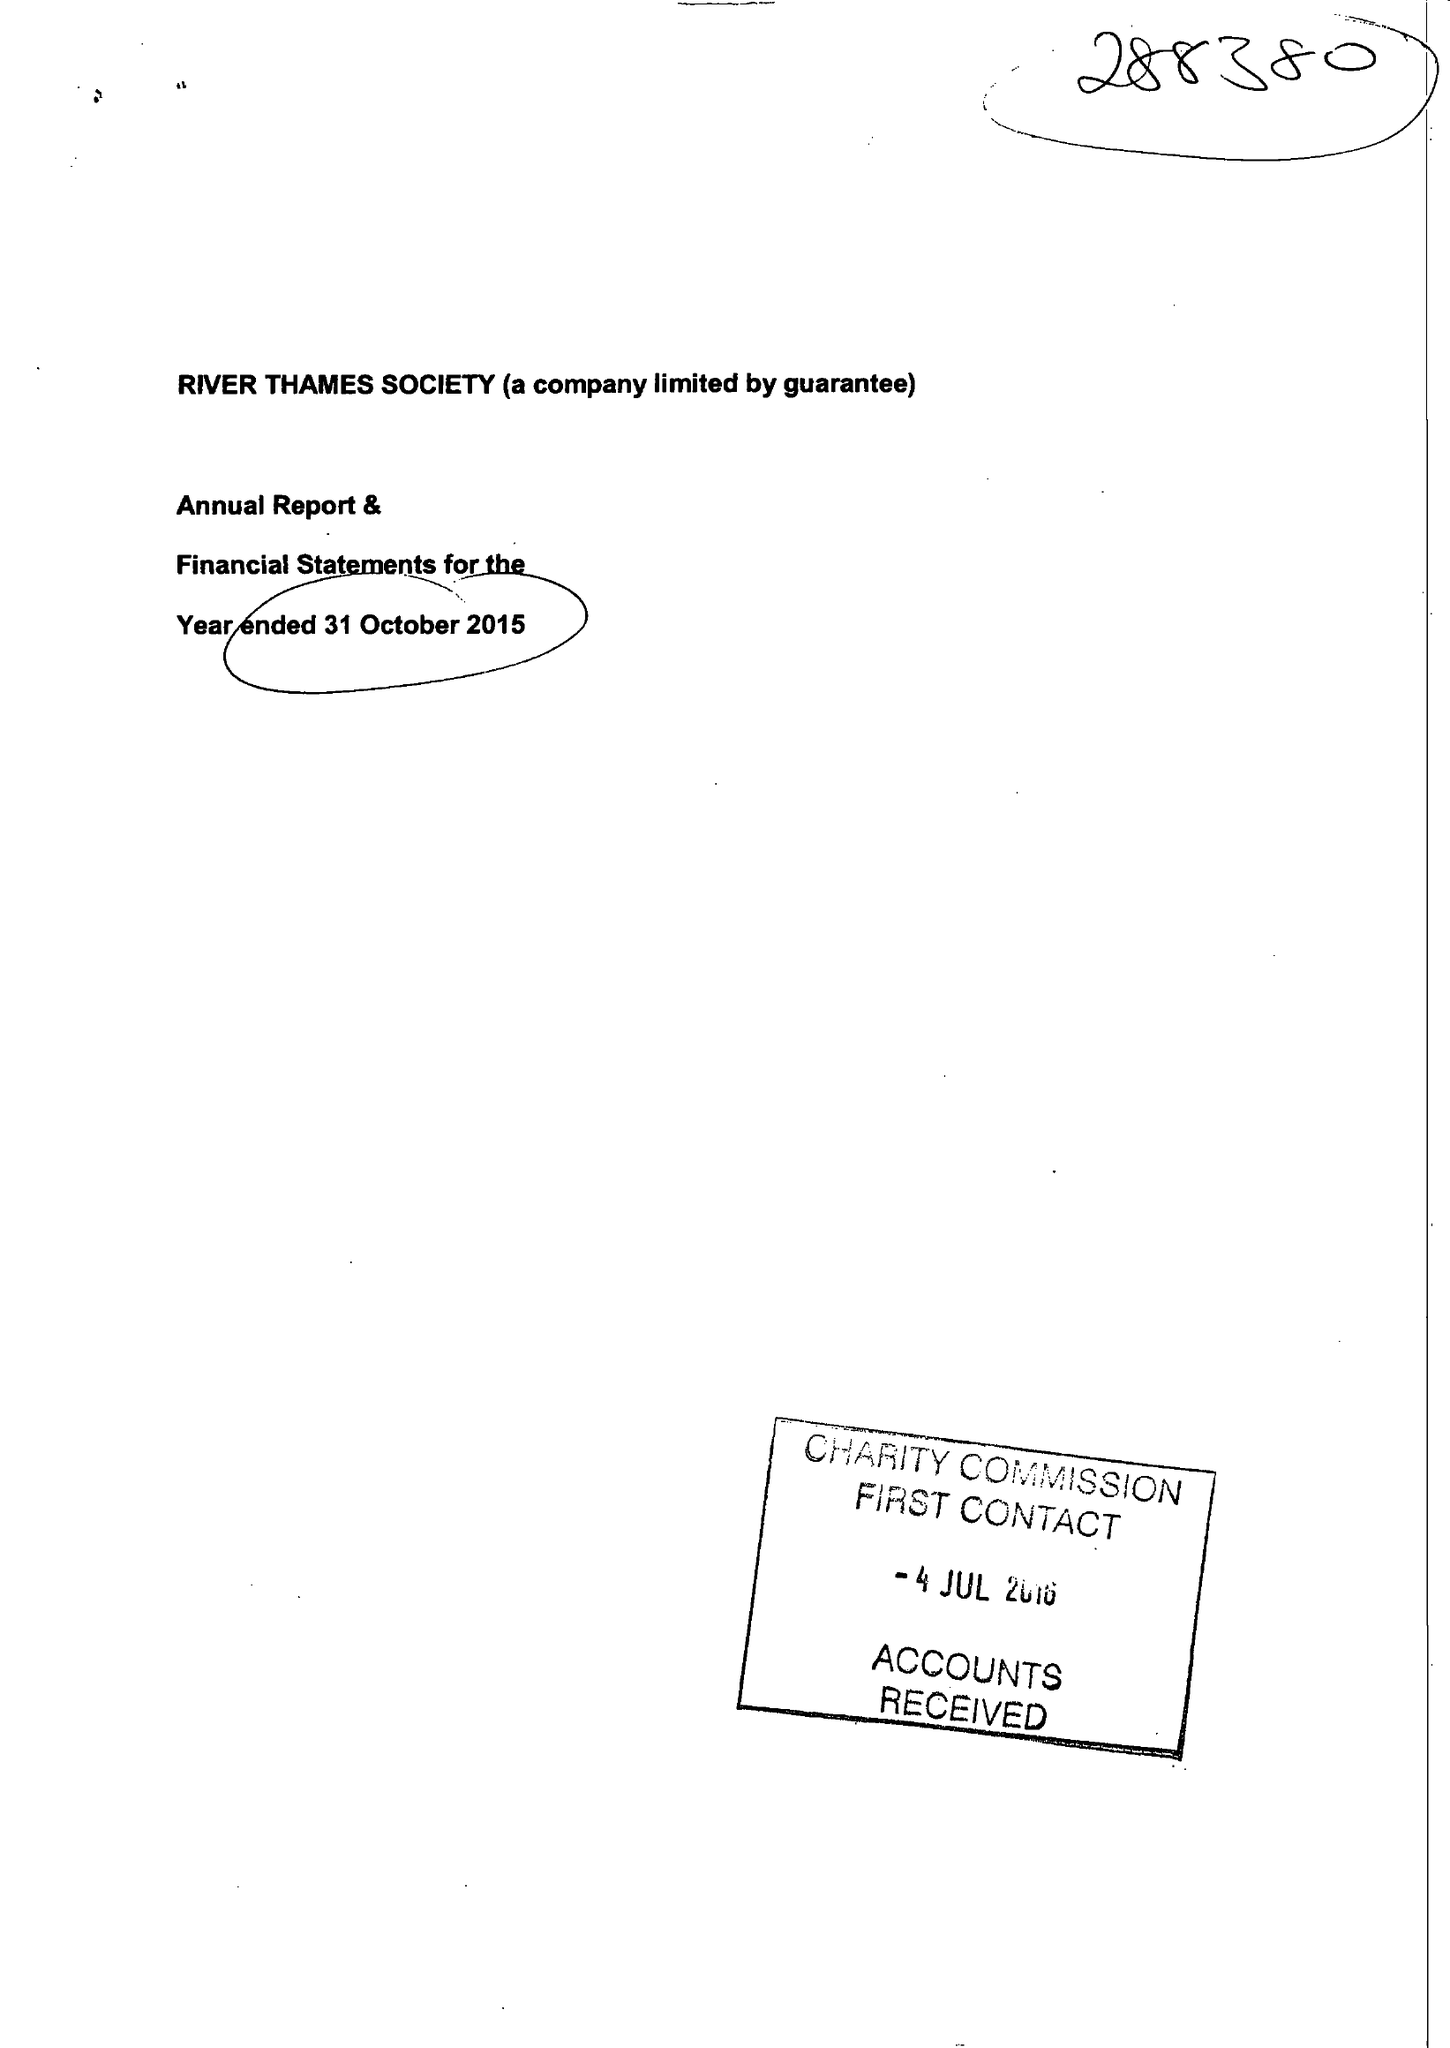What is the value for the spending_annually_in_british_pounds?
Answer the question using a single word or phrase. 28071.00 